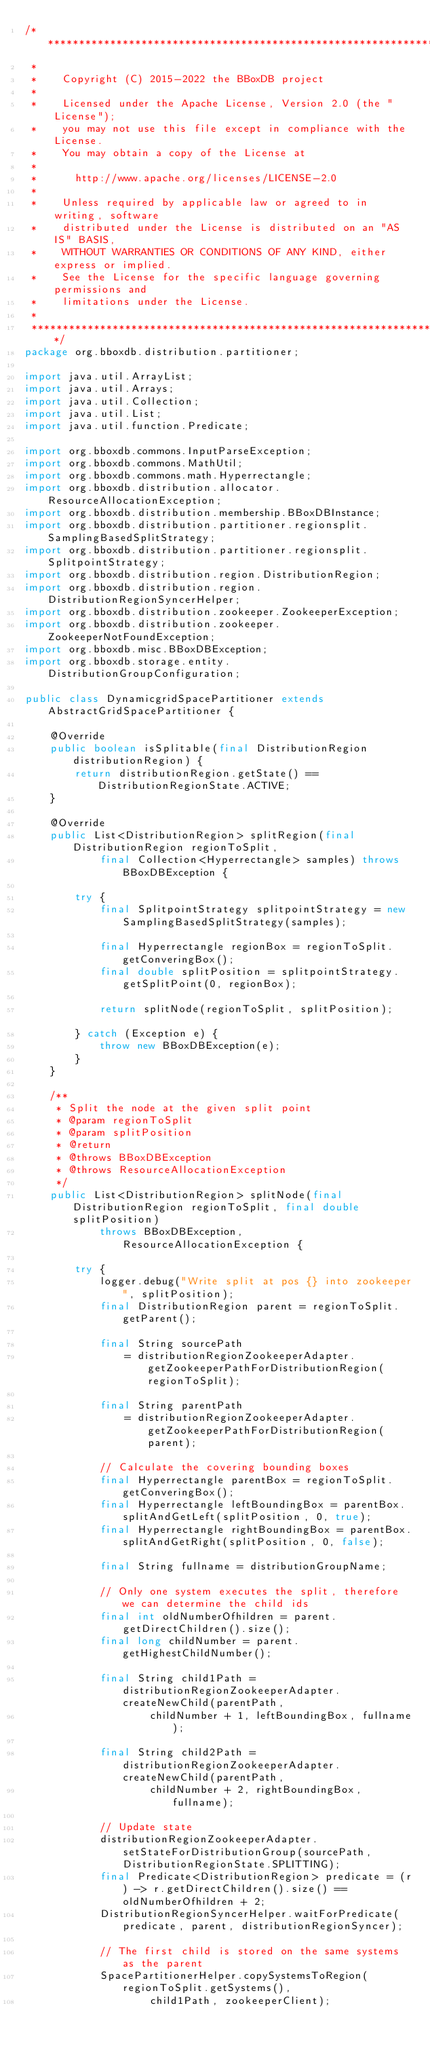Convert code to text. <code><loc_0><loc_0><loc_500><loc_500><_Java_>/*******************************************************************************
 *
 *    Copyright (C) 2015-2022 the BBoxDB project
 *  
 *    Licensed under the Apache License, Version 2.0 (the "License");
 *    you may not use this file except in compliance with the License.
 *    You may obtain a copy of the License at
 *  
 *      http://www.apache.org/licenses/LICENSE-2.0
 *  
 *    Unless required by applicable law or agreed to in writing, software
 *    distributed under the License is distributed on an "AS IS" BASIS,
 *    WITHOUT WARRANTIES OR CONDITIONS OF ANY KIND, either express or implied.
 *    See the License for the specific language governing permissions and
 *    limitations under the License. 
 *    
 *******************************************************************************/
package org.bboxdb.distribution.partitioner;

import java.util.ArrayList;
import java.util.Arrays;
import java.util.Collection;
import java.util.List;
import java.util.function.Predicate;

import org.bboxdb.commons.InputParseException;
import org.bboxdb.commons.MathUtil;
import org.bboxdb.commons.math.Hyperrectangle;
import org.bboxdb.distribution.allocator.ResourceAllocationException;
import org.bboxdb.distribution.membership.BBoxDBInstance;
import org.bboxdb.distribution.partitioner.regionsplit.SamplingBasedSplitStrategy;
import org.bboxdb.distribution.partitioner.regionsplit.SplitpointStrategy;
import org.bboxdb.distribution.region.DistributionRegion;
import org.bboxdb.distribution.region.DistributionRegionSyncerHelper;
import org.bboxdb.distribution.zookeeper.ZookeeperException;
import org.bboxdb.distribution.zookeeper.ZookeeperNotFoundException;
import org.bboxdb.misc.BBoxDBException;
import org.bboxdb.storage.entity.DistributionGroupConfiguration;

public class DynamicgridSpacePartitioner extends AbstractGridSpacePartitioner {

	@Override
	public boolean isSplitable(final DistributionRegion distributionRegion) {
		return distributionRegion.getState() == DistributionRegionState.ACTIVE;
	}

	@Override
	public List<DistributionRegion> splitRegion(final DistributionRegion regionToSplit, 
			final Collection<Hyperrectangle> samples) throws BBoxDBException {
		
		try {
			final SplitpointStrategy splitpointStrategy = new SamplingBasedSplitStrategy(samples);
			
			final Hyperrectangle regionBox = regionToSplit.getConveringBox();
			final double splitPosition = splitpointStrategy.getSplitPoint(0, regionBox);
			
			return splitNode(regionToSplit, splitPosition);			
		} catch (Exception e) {
			throw new BBoxDBException(e);
		} 	
	}
	
	/**
	 * Split the node at the given split point
	 * @param regionToSplit
	 * @param splitPosition
	 * @return 
	 * @throws BBoxDBException
	 * @throws ResourceAllocationException 
	 */
	public List<DistributionRegion> splitNode(final DistributionRegion regionToSplit, final double splitPosition)
			throws BBoxDBException, ResourceAllocationException {
		
		try {
			logger.debug("Write split at pos {} into zookeeper", splitPosition);
			final DistributionRegion parent = regionToSplit.getParent();
			
			final String sourcePath 
				= distributionRegionZookeeperAdapter.getZookeeperPathForDistributionRegion(regionToSplit);

			final String parentPath 
				= distributionRegionZookeeperAdapter.getZookeeperPathForDistributionRegion(parent);
			
			// Calculate the covering bounding boxes
			final Hyperrectangle parentBox = regionToSplit.getConveringBox();
			final Hyperrectangle leftBoundingBox = parentBox.splitAndGetLeft(splitPosition, 0, true);
			final Hyperrectangle rightBoundingBox = parentBox.splitAndGetRight(splitPosition, 0, false);
			
			final String fullname = distributionGroupName;
			
			// Only one system executes the split, therefore we can determine the child ids
			final int oldNumberOfhildren = parent.getDirectChildren().size();
			final long childNumber = parent.getHighestChildNumber();
			
			final String child1Path = distributionRegionZookeeperAdapter.createNewChild(parentPath, 
					childNumber + 1, leftBoundingBox, fullname);
			
			final String child2Path = distributionRegionZookeeperAdapter.createNewChild(parentPath, 
					childNumber + 2, rightBoundingBox, fullname);

			// Update state
			distributionRegionZookeeperAdapter.setStateForDistributionGroup(sourcePath, DistributionRegionState.SPLITTING);
			final Predicate<DistributionRegion> predicate = (r) -> r.getDirectChildren().size() == oldNumberOfhildren + 2;
			DistributionRegionSyncerHelper.waitForPredicate(predicate, parent, distributionRegionSyncer);
						
			// The first child is stored on the same systems as the parent
			SpacePartitionerHelper.copySystemsToRegion(regionToSplit.getSystems(), 
					child1Path, zookeeperClient);
</code> 